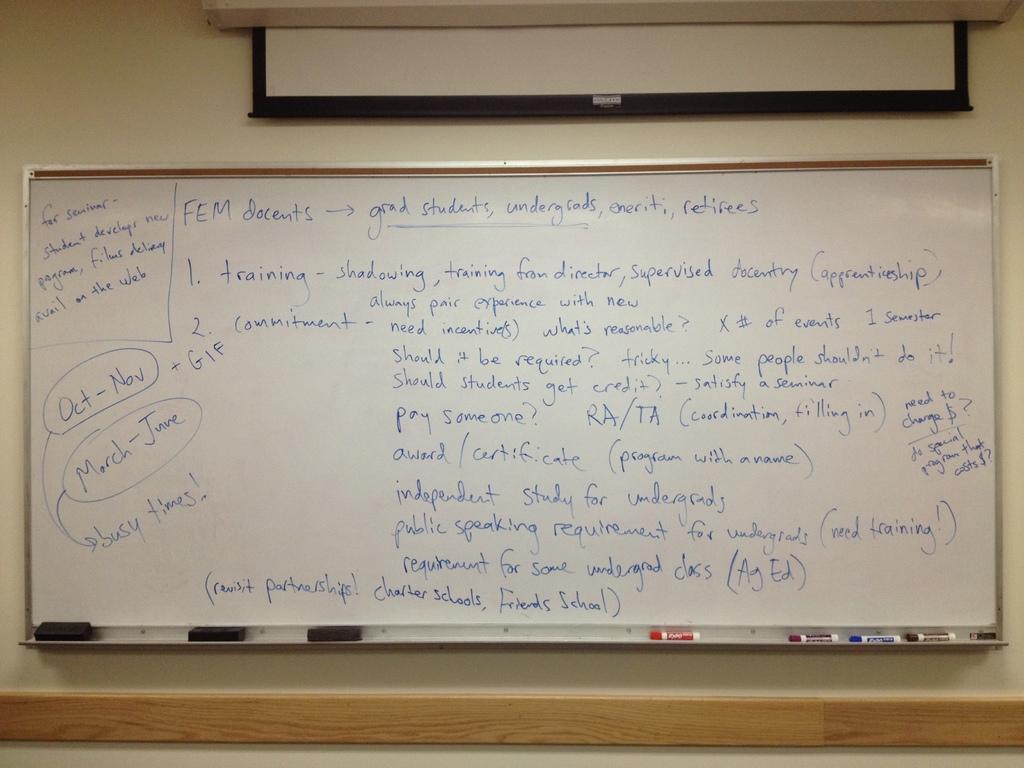Can you describe this image briefly? In this image I can see a white colour board, a projector's screen, few dusters, few markers and on this board I can see something is written. 